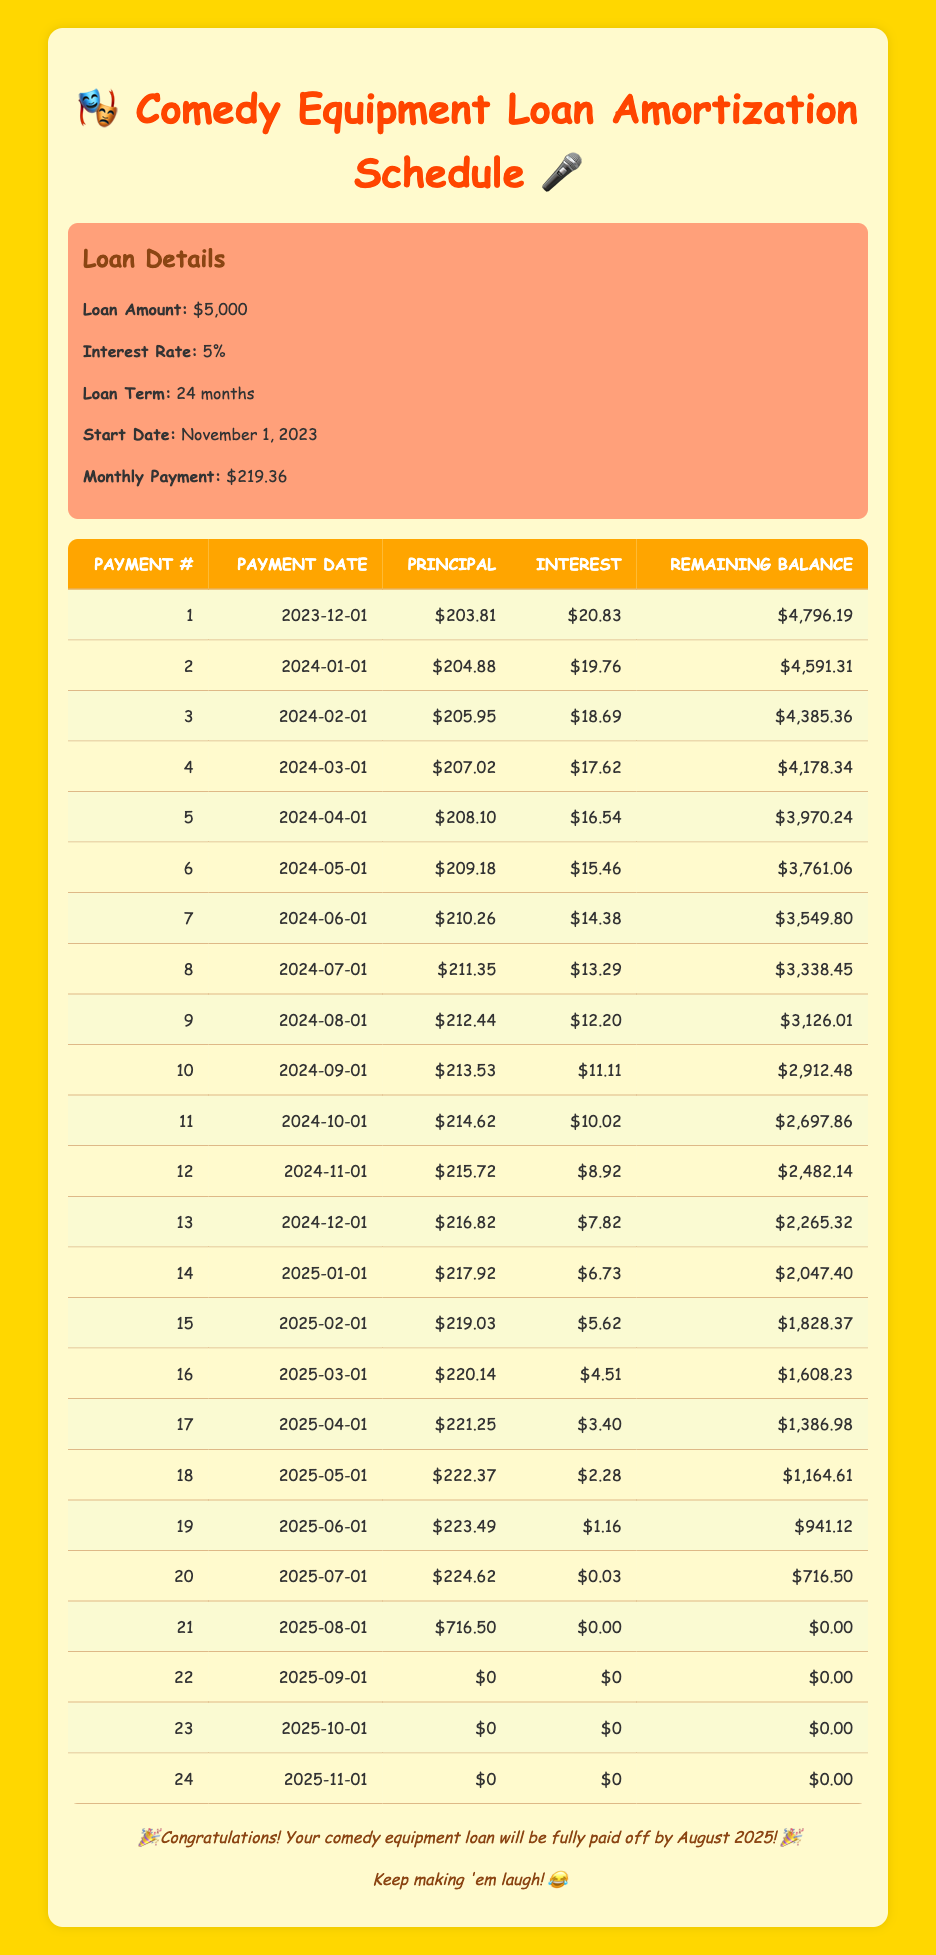What is the total principal paid after the first three months? To find the total principal paid after the first three months, we can sum the principal payments of the first three entries: 203.81 + 204.88 + 205.95. This equals 614.64.
Answer: 614.64 What is the monthly payment amount? The monthly payment is clearly stated in the loan details section of the table as $219.36.
Answer: 219.36 Is the interest payment for the first month more than $20? The interest payment for the first month is $20.83, which is indeed greater than $20. Therefore, the answer is yes.
Answer: Yes What is the remaining balance after the 10th payment? The remaining balance after the 10th payment can be found in the table, which shows it as $2,912.48.
Answer: 2912.48 How much total interest will be paid in the first year? To calculate the total interest paid in the first year, we need to sum the interest payments for the first twelve months. From the table, that adds up to: 20.83 + 19.76 + 18.69 + 17.62 + 16.54 + 15.46 + 14.38 + 13.29 + 12.20 + 11.11 + 10.02 + 8.92 =  17.84 + 84.69 + 14.66 + 11.88 + 9.53 + 8.39 = 123.83. The total interest paid in the first year is 123.83.
Answer: 123.83 Is there any payment with zero interest in the amortization schedule? No payments in the amortization schedule show an interest payment of $0 except the final payment, which is the 22nd, 23rd, and 24th payments. Before the 21st, each payment has at least a minimal interest amount.
Answer: No How much was the principal payment for the 20th payment? According to the table, the principal payment for the 20th entry is $224.62.
Answer: 224.62 What is the total remaining balance after the first half of the loan term (12 months)? To find the total remaining balance after the first half of the loan term, we look at the remaining balance after the 12th payment, which is recorded in the table as $2,482.14.
Answer: 2482.14 What was the interest payment for the 18th month? The interest payment for the 18th month is $2.28, which can be directly referenced from the amortization schedule.
Answer: 2.28 